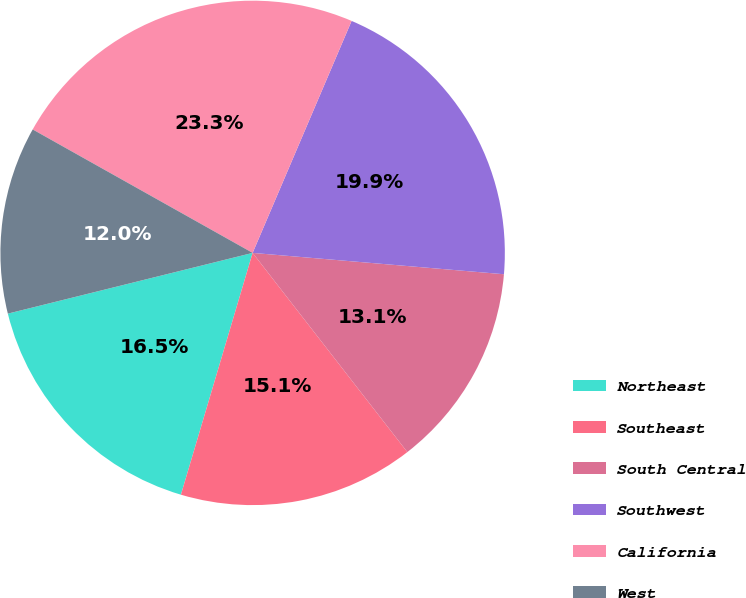Convert chart. <chart><loc_0><loc_0><loc_500><loc_500><pie_chart><fcel>Northeast<fcel>Southeast<fcel>South Central<fcel>Southwest<fcel>California<fcel>West<nl><fcel>16.54%<fcel>15.1%<fcel>13.14%<fcel>19.93%<fcel>23.28%<fcel>12.01%<nl></chart> 